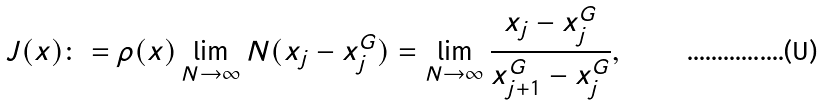<formula> <loc_0><loc_0><loc_500><loc_500>J ( x ) \colon = \rho ( x ) \lim _ { N \to \infty } N ( x _ { j } - x _ { j } ^ { G } ) = \lim _ { N \to \infty } \frac { x _ { j } - x _ { j } ^ { G } } { x _ { j + 1 } ^ { G } - x _ { j } ^ { G } } ,</formula> 